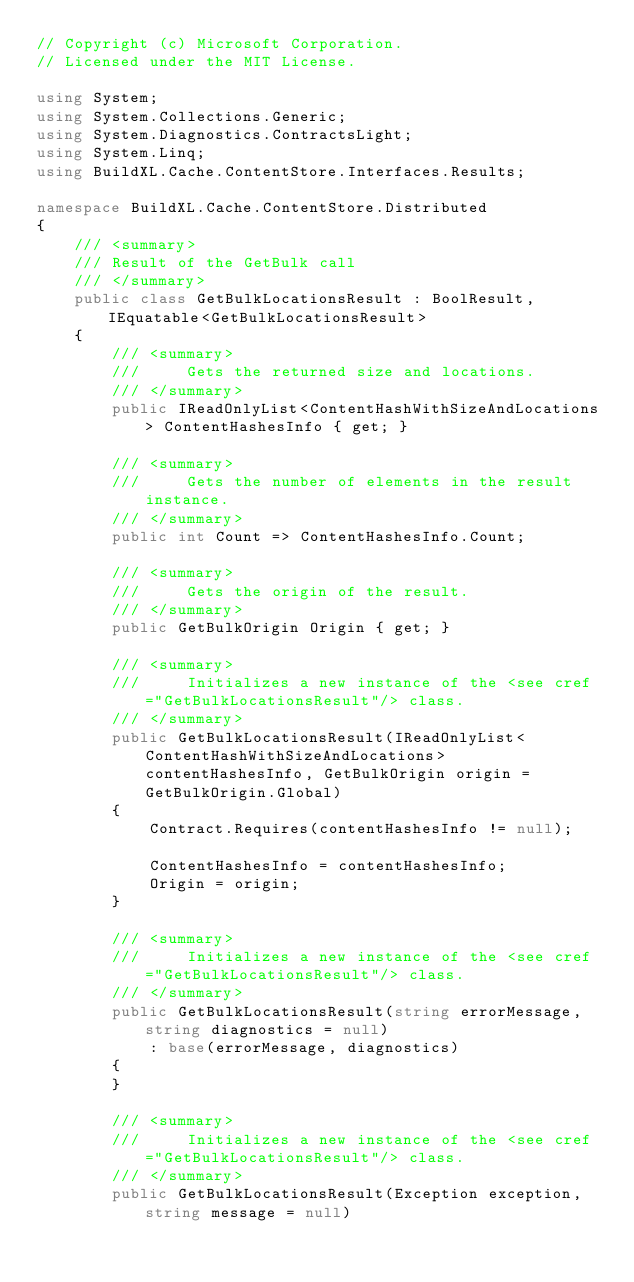Convert code to text. <code><loc_0><loc_0><loc_500><loc_500><_C#_>// Copyright (c) Microsoft Corporation.
// Licensed under the MIT License.

using System;
using System.Collections.Generic;
using System.Diagnostics.ContractsLight;
using System.Linq;
using BuildXL.Cache.ContentStore.Interfaces.Results;

namespace BuildXL.Cache.ContentStore.Distributed
{
    /// <summary>
    /// Result of the GetBulk call
    /// </summary>
    public class GetBulkLocationsResult : BoolResult, IEquatable<GetBulkLocationsResult>
    {
        /// <summary>
        ///     Gets the returned size and locations.
        /// </summary>
        public IReadOnlyList<ContentHashWithSizeAndLocations> ContentHashesInfo { get; }

        /// <summary>
        ///     Gets the number of elements in the result instance.
        /// </summary>
        public int Count => ContentHashesInfo.Count;

        /// <summary>
        ///     Gets the origin of the result.
        /// </summary>
        public GetBulkOrigin Origin { get; }

        /// <summary>
        ///     Initializes a new instance of the <see cref="GetBulkLocationsResult"/> class.
        /// </summary>
        public GetBulkLocationsResult(IReadOnlyList<ContentHashWithSizeAndLocations> contentHashesInfo, GetBulkOrigin origin = GetBulkOrigin.Global)
        {
            Contract.Requires(contentHashesInfo != null);

            ContentHashesInfo = contentHashesInfo;
            Origin = origin;
        }

        /// <summary>
        ///     Initializes a new instance of the <see cref="GetBulkLocationsResult"/> class.
        /// </summary>
        public GetBulkLocationsResult(string errorMessage, string diagnostics = null)
            : base(errorMessage, diagnostics)
        {
        }

        /// <summary>
        ///     Initializes a new instance of the <see cref="GetBulkLocationsResult"/> class.
        /// </summary>
        public GetBulkLocationsResult(Exception exception, string message = null)</code> 